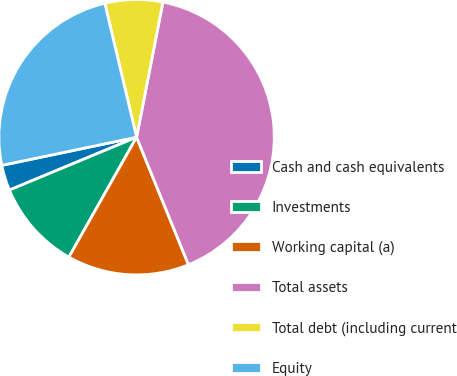<chart> <loc_0><loc_0><loc_500><loc_500><pie_chart><fcel>Cash and cash equivalents<fcel>Investments<fcel>Working capital (a)<fcel>Total assets<fcel>Total debt (including current<fcel>Equity<nl><fcel>2.99%<fcel>10.55%<fcel>14.33%<fcel>40.78%<fcel>6.77%<fcel>24.57%<nl></chart> 